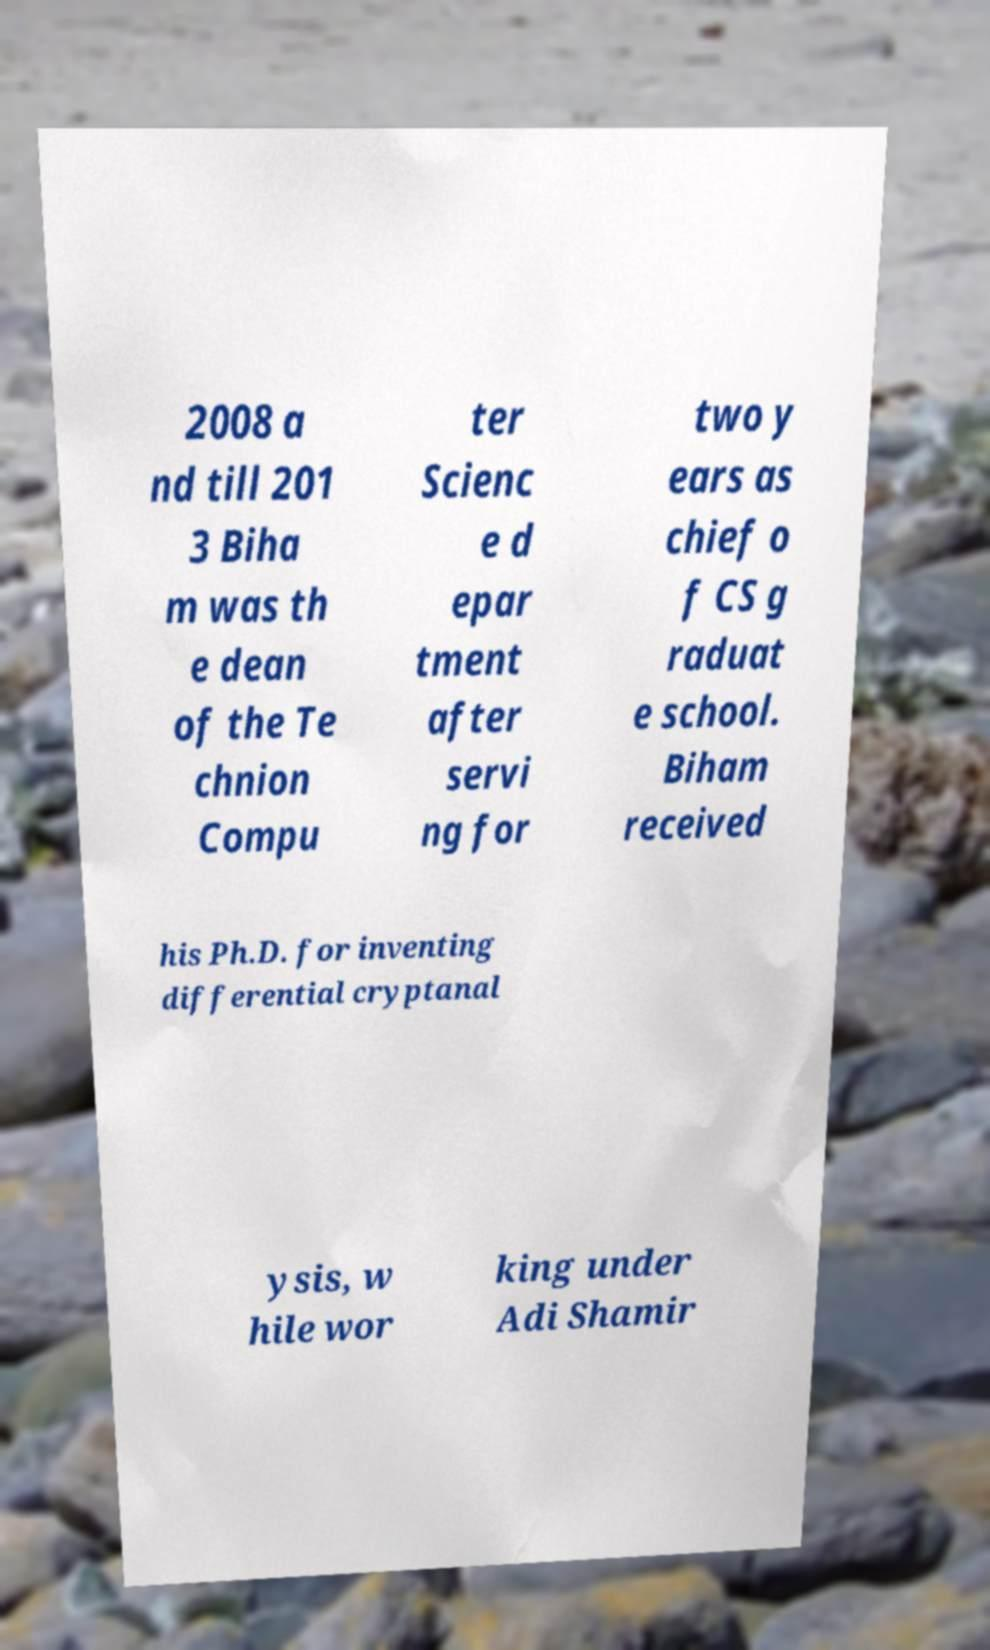Can you accurately transcribe the text from the provided image for me? 2008 a nd till 201 3 Biha m was th e dean of the Te chnion Compu ter Scienc e d epar tment after servi ng for two y ears as chief o f CS g raduat e school. Biham received his Ph.D. for inventing differential cryptanal ysis, w hile wor king under Adi Shamir 